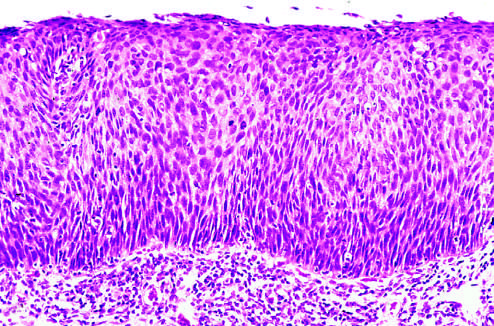what shows that the entire thickness of the epithelium is replaced by atypical dysplastic cells?
Answer the question using a single word or phrase. The low-power view 